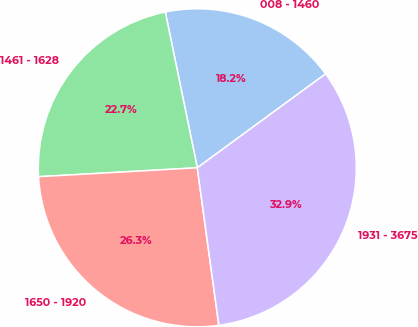<chart> <loc_0><loc_0><loc_500><loc_500><pie_chart><fcel>008 - 1460<fcel>1461 - 1628<fcel>1650 - 1920<fcel>1931 - 3675<nl><fcel>18.17%<fcel>22.67%<fcel>26.27%<fcel>32.9%<nl></chart> 